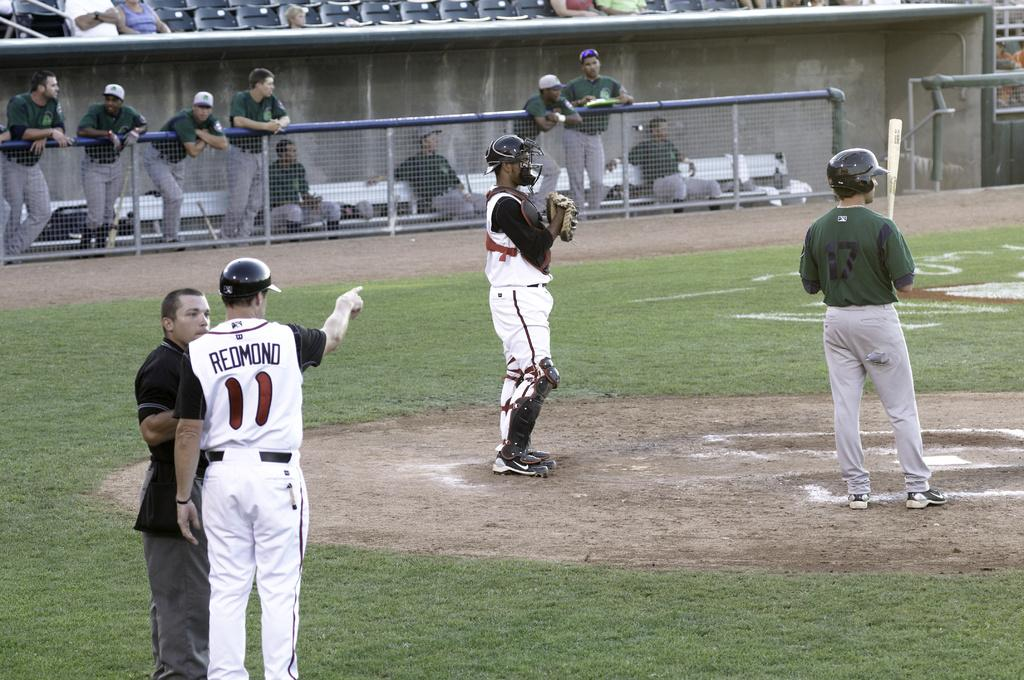<image>
Render a clear and concise summary of the photo. player in white number 11 redmond talking to ref and pointing 